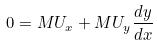Convert formula to latex. <formula><loc_0><loc_0><loc_500><loc_500>0 = M U _ { x } + M U _ { y } \frac { d y } { d x }</formula> 